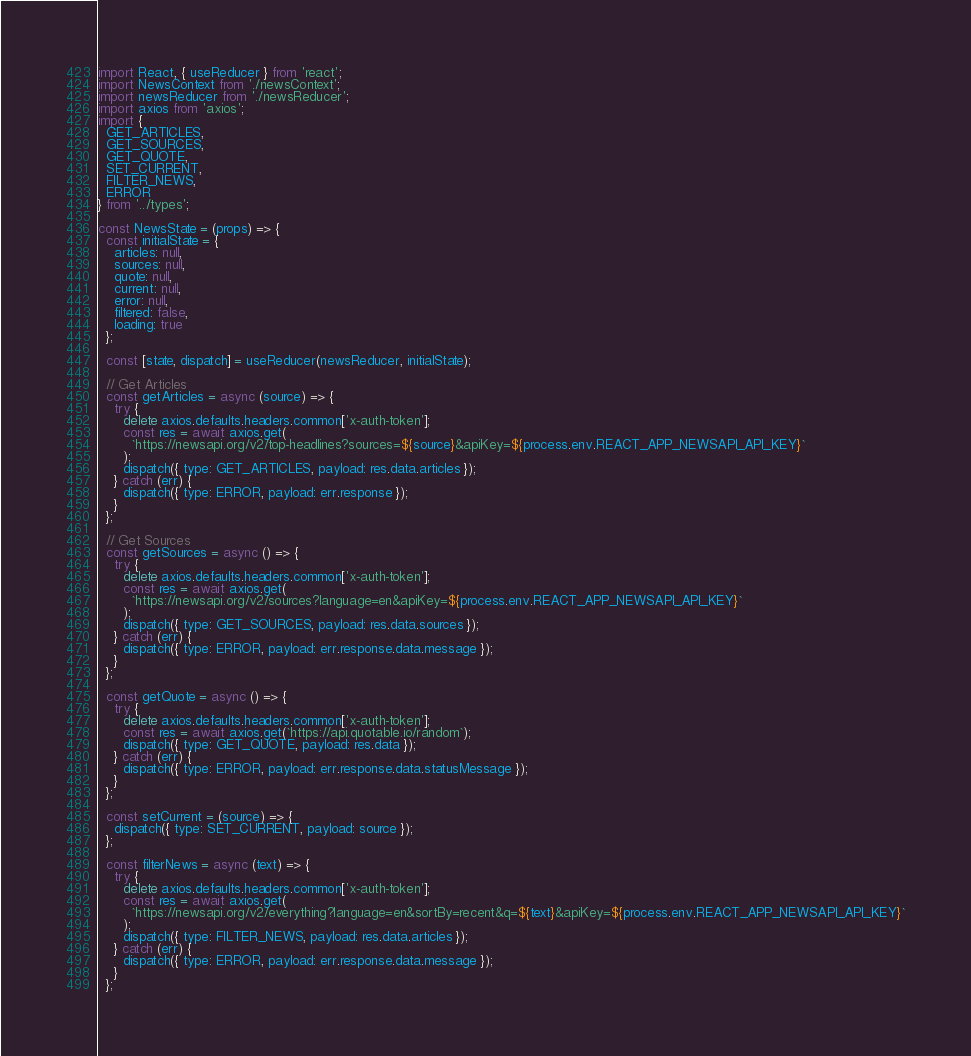Convert code to text. <code><loc_0><loc_0><loc_500><loc_500><_JavaScript_>import React, { useReducer } from 'react';
import NewsContext from './newsContext';
import newsReducer from './newsReducer';
import axios from 'axios';
import {
  GET_ARTICLES,
  GET_SOURCES,
  GET_QUOTE,
  SET_CURRENT,
  FILTER_NEWS,
  ERROR
} from '../types';

const NewsState = (props) => {
  const initialState = {
    articles: null,
    sources: null,
    quote: null,
    current: null,
    error: null,
    filtered: false,
    loading: true
  };

  const [state, dispatch] = useReducer(newsReducer, initialState);

  // Get Articles
  const getArticles = async (source) => {
    try {
      delete axios.defaults.headers.common['x-auth-token'];
      const res = await axios.get(
        `https://newsapi.org/v2/top-headlines?sources=${source}&apiKey=${process.env.REACT_APP_NEWSAPI_API_KEY}`
      );
      dispatch({ type: GET_ARTICLES, payload: res.data.articles });
    } catch (err) {
      dispatch({ type: ERROR, payload: err.response });
    }
  };

  // Get Sources
  const getSources = async () => {
    try {
      delete axios.defaults.headers.common['x-auth-token'];
      const res = await axios.get(
        `https://newsapi.org/v2/sources?language=en&apiKey=${process.env.REACT_APP_NEWSAPI_API_KEY}`
      );
      dispatch({ type: GET_SOURCES, payload: res.data.sources });
    } catch (err) {
      dispatch({ type: ERROR, payload: err.response.data.message });
    }
  };

  const getQuote = async () => {
    try {
      delete axios.defaults.headers.common['x-auth-token'];
      const res = await axios.get(`https://api.quotable.io/random`);
      dispatch({ type: GET_QUOTE, payload: res.data });
    } catch (err) {
      dispatch({ type: ERROR, payload: err.response.data.statusMessage });
    }
  };

  const setCurrent = (source) => {
    dispatch({ type: SET_CURRENT, payload: source });
  };

  const filterNews = async (text) => {
    try {
      delete axios.defaults.headers.common['x-auth-token'];
      const res = await axios.get(
        `https://newsapi.org/v2/everything?language=en&sortBy=recent&q=${text}&apiKey=${process.env.REACT_APP_NEWSAPI_API_KEY}`
      );
      dispatch({ type: FILTER_NEWS, payload: res.data.articles });
    } catch (err) {
      dispatch({ type: ERROR, payload: err.response.data.message });
    }
  };
</code> 